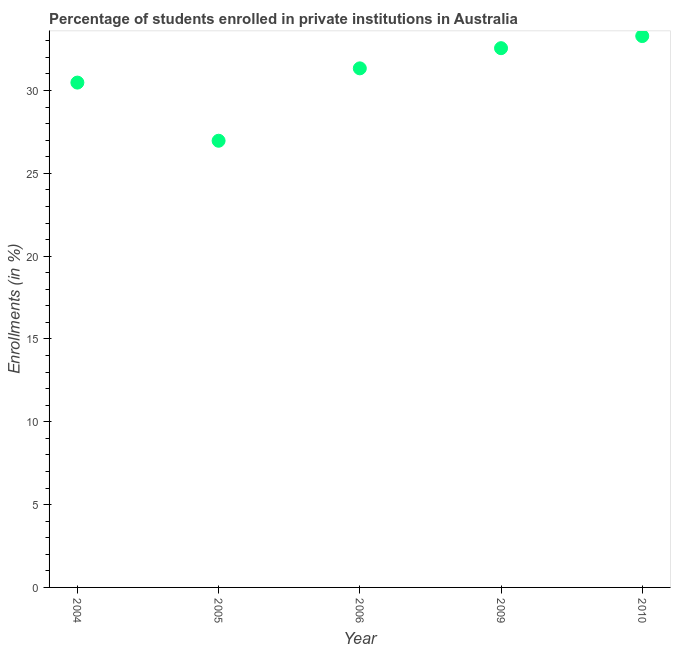What is the enrollments in private institutions in 2004?
Keep it short and to the point. 30.48. Across all years, what is the maximum enrollments in private institutions?
Provide a short and direct response. 33.29. Across all years, what is the minimum enrollments in private institutions?
Offer a very short reply. 26.97. In which year was the enrollments in private institutions maximum?
Your answer should be very brief. 2010. What is the sum of the enrollments in private institutions?
Keep it short and to the point. 154.62. What is the difference between the enrollments in private institutions in 2004 and 2006?
Your answer should be compact. -0.86. What is the average enrollments in private institutions per year?
Offer a very short reply. 30.92. What is the median enrollments in private institutions?
Offer a terse response. 31.34. Do a majority of the years between 2006 and 2004 (inclusive) have enrollments in private institutions greater than 7 %?
Keep it short and to the point. No. What is the ratio of the enrollments in private institutions in 2005 to that in 2010?
Provide a short and direct response. 0.81. What is the difference between the highest and the second highest enrollments in private institutions?
Keep it short and to the point. 0.73. What is the difference between the highest and the lowest enrollments in private institutions?
Provide a succinct answer. 6.32. In how many years, is the enrollments in private institutions greater than the average enrollments in private institutions taken over all years?
Offer a terse response. 3. Does the enrollments in private institutions monotonically increase over the years?
Your response must be concise. No. How many dotlines are there?
Offer a very short reply. 1. How many years are there in the graph?
Provide a succinct answer. 5. What is the title of the graph?
Your answer should be very brief. Percentage of students enrolled in private institutions in Australia. What is the label or title of the Y-axis?
Your answer should be compact. Enrollments (in %). What is the Enrollments (in %) in 2004?
Your response must be concise. 30.48. What is the Enrollments (in %) in 2005?
Your answer should be very brief. 26.97. What is the Enrollments (in %) in 2006?
Your answer should be compact. 31.34. What is the Enrollments (in %) in 2009?
Make the answer very short. 32.55. What is the Enrollments (in %) in 2010?
Your answer should be compact. 33.29. What is the difference between the Enrollments (in %) in 2004 and 2005?
Offer a very short reply. 3.51. What is the difference between the Enrollments (in %) in 2004 and 2006?
Your answer should be compact. -0.86. What is the difference between the Enrollments (in %) in 2004 and 2009?
Provide a short and direct response. -2.08. What is the difference between the Enrollments (in %) in 2004 and 2010?
Your answer should be compact. -2.81. What is the difference between the Enrollments (in %) in 2005 and 2006?
Keep it short and to the point. -4.37. What is the difference between the Enrollments (in %) in 2005 and 2009?
Provide a short and direct response. -5.59. What is the difference between the Enrollments (in %) in 2005 and 2010?
Make the answer very short. -6.32. What is the difference between the Enrollments (in %) in 2006 and 2009?
Offer a terse response. -1.22. What is the difference between the Enrollments (in %) in 2006 and 2010?
Offer a terse response. -1.95. What is the difference between the Enrollments (in %) in 2009 and 2010?
Your answer should be very brief. -0.73. What is the ratio of the Enrollments (in %) in 2004 to that in 2005?
Give a very brief answer. 1.13. What is the ratio of the Enrollments (in %) in 2004 to that in 2009?
Make the answer very short. 0.94. What is the ratio of the Enrollments (in %) in 2004 to that in 2010?
Your response must be concise. 0.92. What is the ratio of the Enrollments (in %) in 2005 to that in 2006?
Ensure brevity in your answer.  0.86. What is the ratio of the Enrollments (in %) in 2005 to that in 2009?
Offer a terse response. 0.83. What is the ratio of the Enrollments (in %) in 2005 to that in 2010?
Your answer should be very brief. 0.81. What is the ratio of the Enrollments (in %) in 2006 to that in 2009?
Make the answer very short. 0.96. What is the ratio of the Enrollments (in %) in 2006 to that in 2010?
Make the answer very short. 0.94. What is the ratio of the Enrollments (in %) in 2009 to that in 2010?
Offer a very short reply. 0.98. 